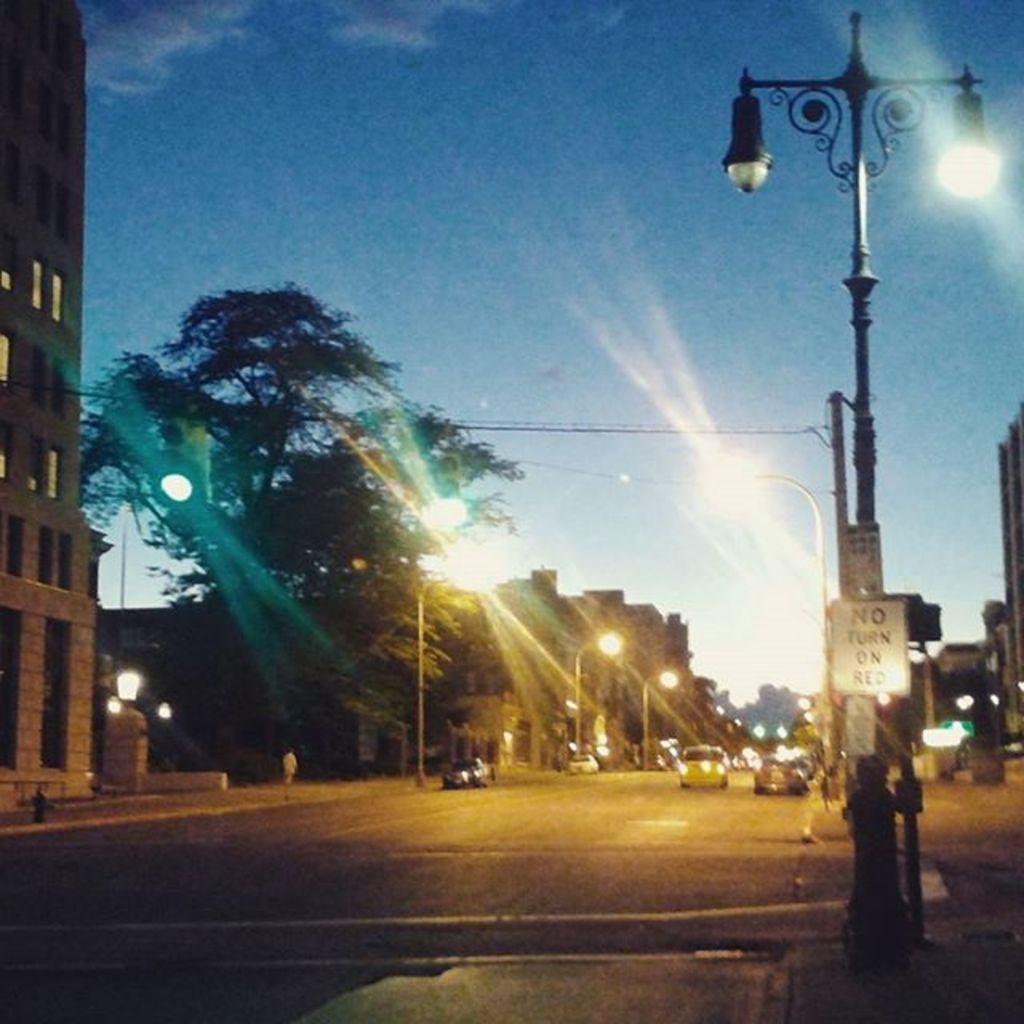What type of vehicles can be seen on the road in the image? There are cars on the road in the image. What structures are present alongside the road? Street lights are present on either side of the road. What can be seen on the left side of the image? Trees and buildings are visible on the left side of the image. What is visible in the sky in the image? The sky is visible in the image. What color is the pocket on the car in the image? There is no pocket visible on any of the cars in the image. 